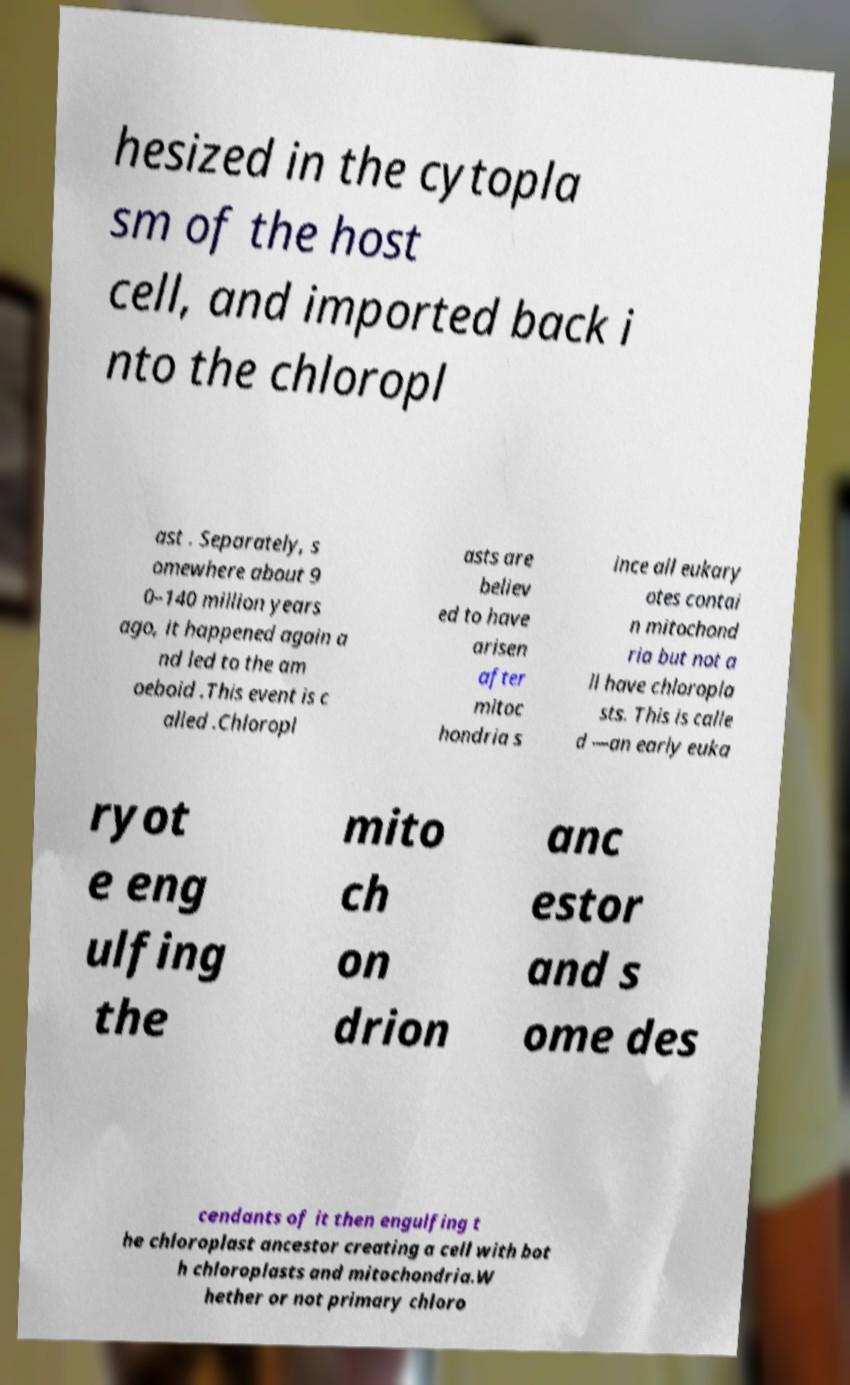Please read and relay the text visible in this image. What does it say? hesized in the cytopla sm of the host cell, and imported back i nto the chloropl ast . Separately, s omewhere about 9 0–140 million years ago, it happened again a nd led to the am oeboid .This event is c alled .Chloropl asts are believ ed to have arisen after mitoc hondria s ince all eukary otes contai n mitochond ria but not a ll have chloropla sts. This is calle d —an early euka ryot e eng ulfing the mito ch on drion anc estor and s ome des cendants of it then engulfing t he chloroplast ancestor creating a cell with bot h chloroplasts and mitochondria.W hether or not primary chloro 